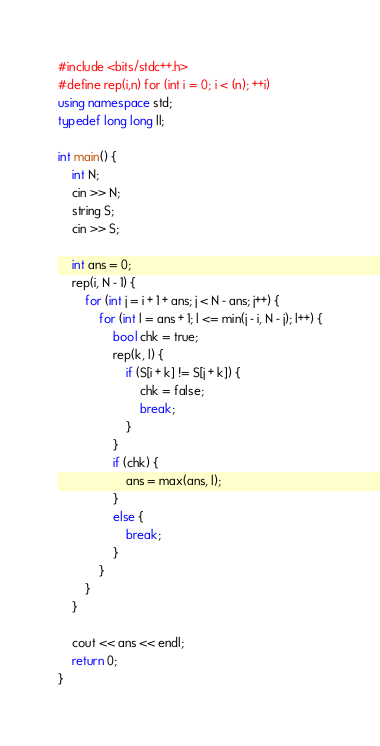<code> <loc_0><loc_0><loc_500><loc_500><_C++_>#include <bits/stdc++.h>
#define rep(i,n) for (int i = 0; i < (n); ++i)
using namespace std;
typedef long long ll;

int main() {
	int N;
	cin >> N;
	string S;
	cin >> S;

	int ans = 0;
	rep(i, N - 1) {
		for (int j = i + 1 + ans; j < N - ans; j++) {
			for (int l = ans + 1; l <= min(j - i, N - j); l++) {
				bool chk = true;
				rep(k, l) {
					if (S[i + k] != S[j + k]) {
						chk = false;
						break;
					}
				}
				if (chk) {
					ans = max(ans, l);
				}
				else {
					break;
				}
			}
		}
	}

	cout << ans << endl;
	return 0;
}
</code> 